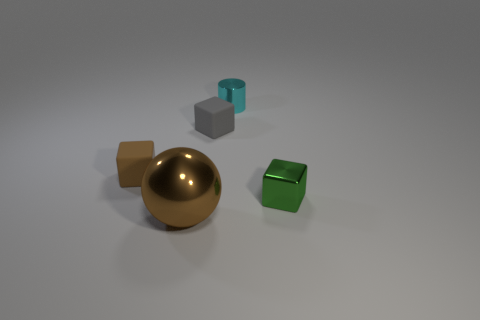Add 3 tiny brown shiny blocks. How many objects exist? 8 Subtract all cylinders. How many objects are left? 4 Subtract 0 yellow cylinders. How many objects are left? 5 Subtract all tiny cylinders. Subtract all brown matte things. How many objects are left? 3 Add 2 tiny green cubes. How many tiny green cubes are left? 3 Add 5 brown cubes. How many brown cubes exist? 6 